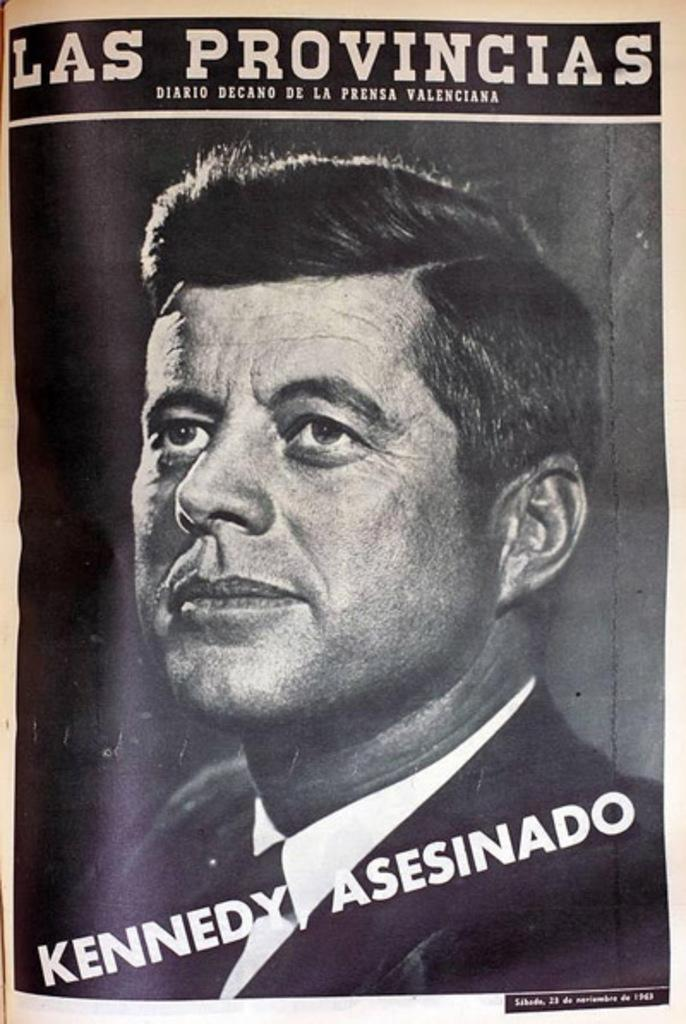Provide a one-sentence caption for the provided image. Magazine cover showing President Kennedy  and the words "Kennedy Asesinado". 